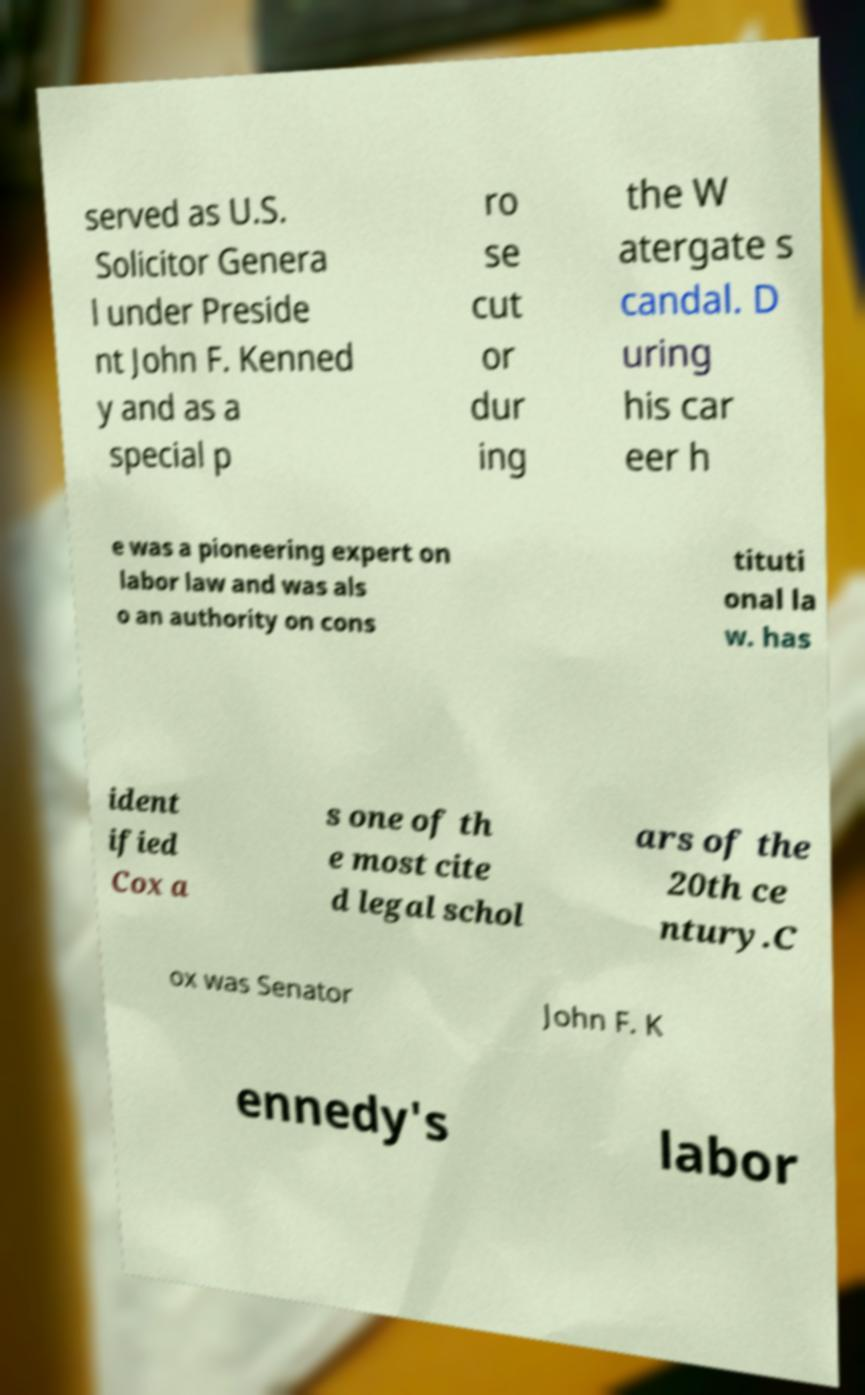Could you extract and type out the text from this image? served as U.S. Solicitor Genera l under Preside nt John F. Kenned y and as a special p ro se cut or dur ing the W atergate s candal. D uring his car eer h e was a pioneering expert on labor law and was als o an authority on cons tituti onal la w. has ident ified Cox a s one of th e most cite d legal schol ars of the 20th ce ntury.C ox was Senator John F. K ennedy's labor 